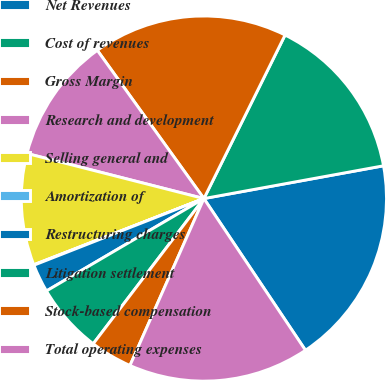<chart> <loc_0><loc_0><loc_500><loc_500><pie_chart><fcel>Net Revenues<fcel>Cost of revenues<fcel>Gross Margin<fcel>Research and development<fcel>Selling general and<fcel>Amortization of<fcel>Restructuring charges<fcel>Litigation settlement<fcel>Stock-based compensation<fcel>Total operating expenses<nl><fcel>18.49%<fcel>14.8%<fcel>17.26%<fcel>11.11%<fcel>9.88%<fcel>0.04%<fcel>2.5%<fcel>6.19%<fcel>3.73%<fcel>16.03%<nl></chart> 